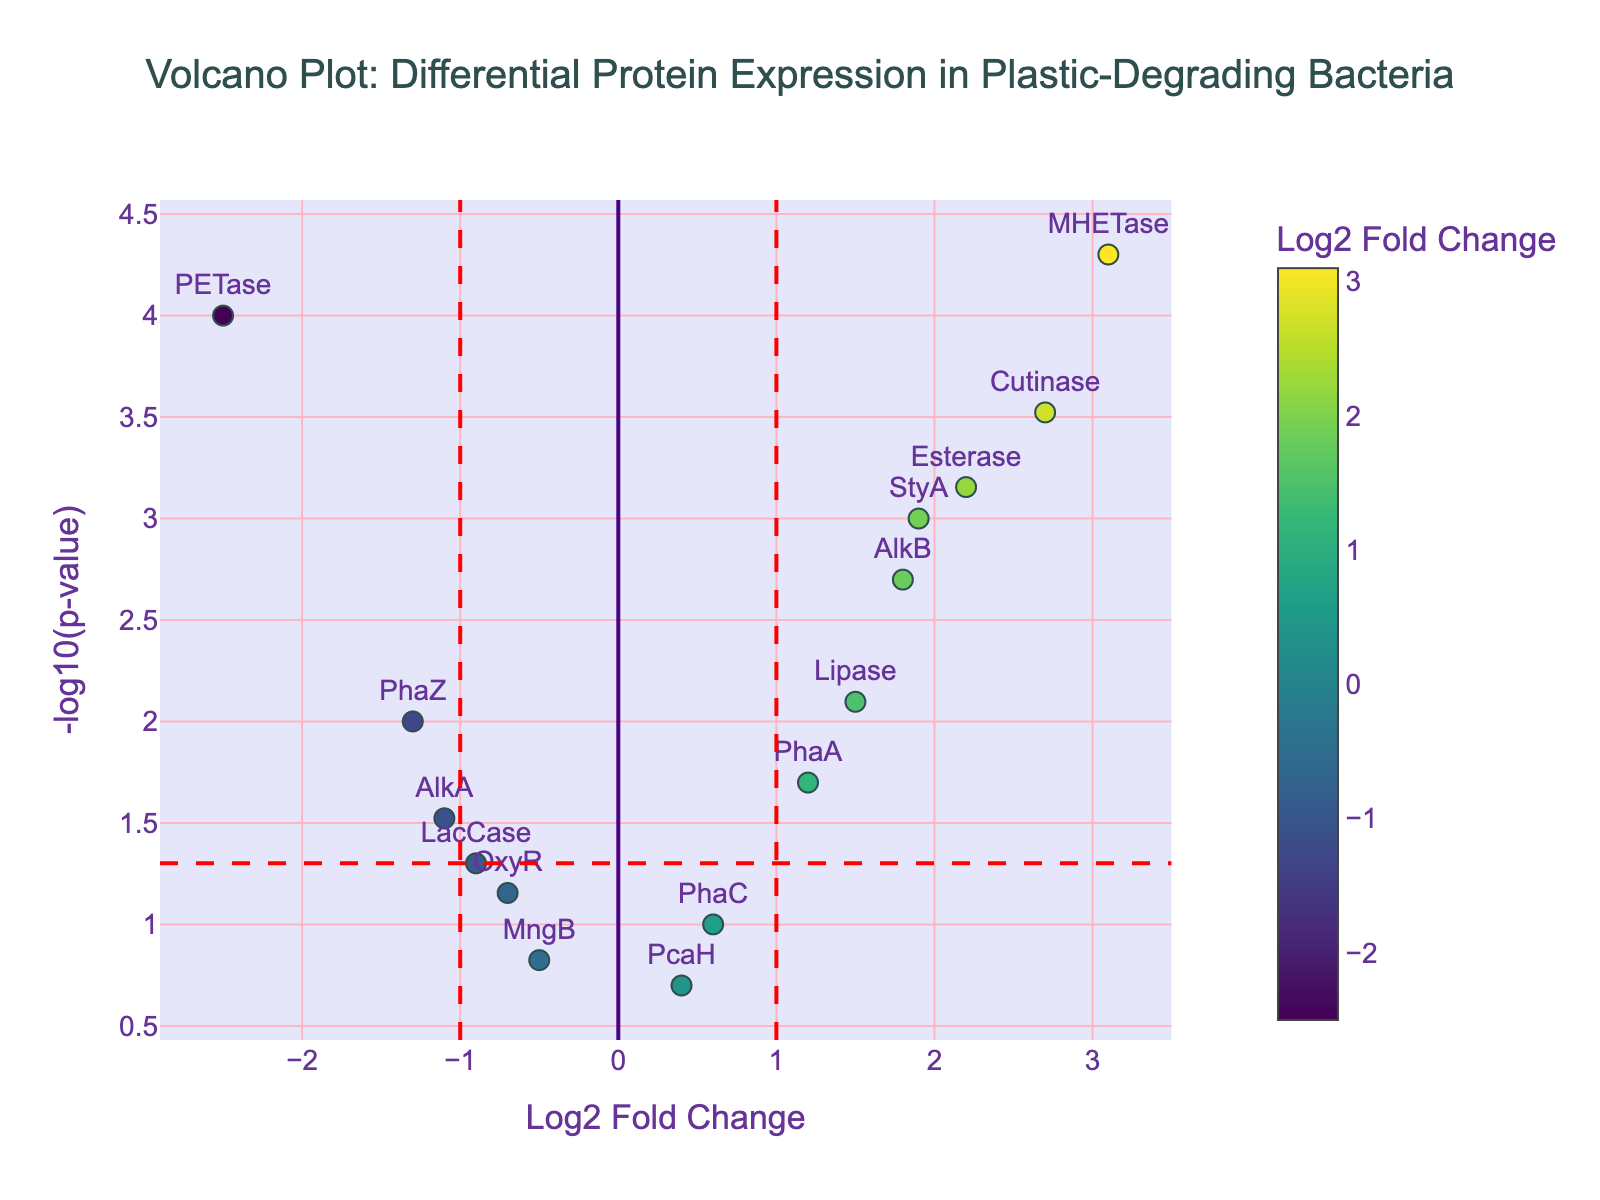Which gene has the highest log2 fold change? To identify the highest log2 fold change, look at the x-axis and find the data point furthest to the right. The gene label next to this point indicates the highest log2 fold change.
Answer: MHETase Which gene has the lowest p-value? P-values are shown on the y-axis in -log10 form. The highest point on the plot corresponds to the lowest p-value.
Answer: MHETase How many genes have a log2 fold change greater than 1? Mark the vertical dashed line at log2 fold change = 1 and count the data points to the right of this line.
Answer: 5 Which gene is not significant (p-value > 0.05) with a decrease in log2 fold change? Genes with p-values > 0.05 lie below the horizontal dashed line. Find the data point below this line on the left side of the vertical line at log2 fold change = 0.
Answer: OxyR Which genes are both upregulated (log2 fold change > 1) and significant (p-value < 0.05)? For genes to be significant, they need to be above the horizontal dashed line (p-value < 0.05). Upregulated genes are those with log2 fold change > 1 (right side of the vertical line at log2 fold change = 1). Check data points that satisfy both conditions.
Answer: MHETase, Cutinase, Esterase, StyA 